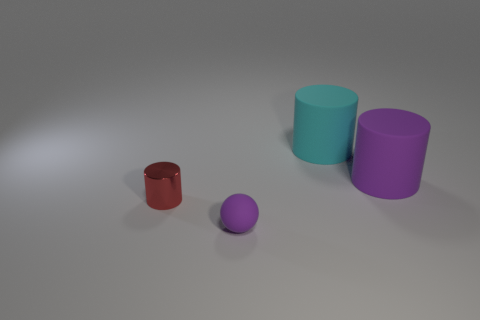Add 2 small purple objects. How many objects exist? 6 Subtract all spheres. How many objects are left? 3 Add 1 tiny red cubes. How many tiny red cubes exist? 1 Subtract 0 cyan cubes. How many objects are left? 4 Subtract all purple objects. Subtract all purple matte balls. How many objects are left? 1 Add 4 red things. How many red things are left? 5 